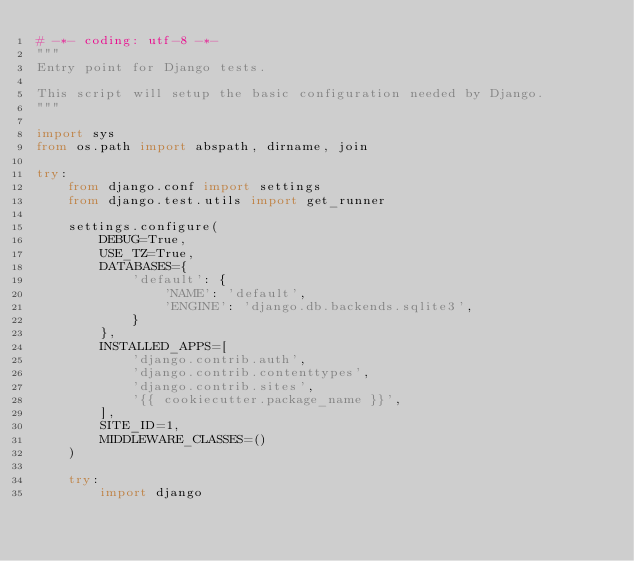<code> <loc_0><loc_0><loc_500><loc_500><_Python_># -*- coding: utf-8 -*-
"""
Entry point for Django tests.

This script will setup the basic configuration needed by Django.
"""

import sys
from os.path import abspath, dirname, join

try:
    from django.conf import settings
    from django.test.utils import get_runner

    settings.configure(
        DEBUG=True,
        USE_TZ=True,
        DATABASES={
            'default': {
                'NAME': 'default',
                'ENGINE': 'django.db.backends.sqlite3',
            }
        },
        INSTALLED_APPS=[
            'django.contrib.auth',
            'django.contrib.contenttypes',
            'django.contrib.sites',
            '{{ cookiecutter.package_name }}',
        ],
        SITE_ID=1,
        MIDDLEWARE_CLASSES=()
    )

    try:
        import django</code> 